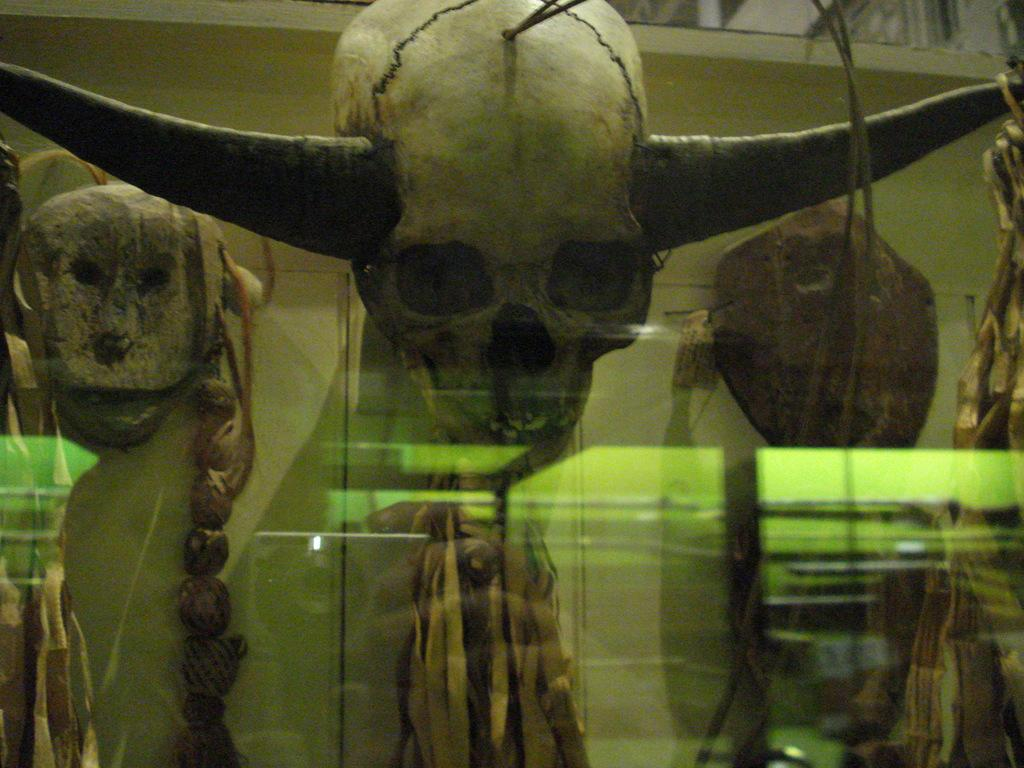What type of wall is present in the image? There is a glass wall in the image. What can be seen through the glass wall? A skull with horns is visible through the glass wall. Are there any other objects visible through the glass wall? Yes, there are other objects visible through the glass wall. What type of grape is being used as a design element on the metal surface in the image? There is no grape or metal surface present in the image. The image features a glass wall with a skull with horns and other objects visible through it. 